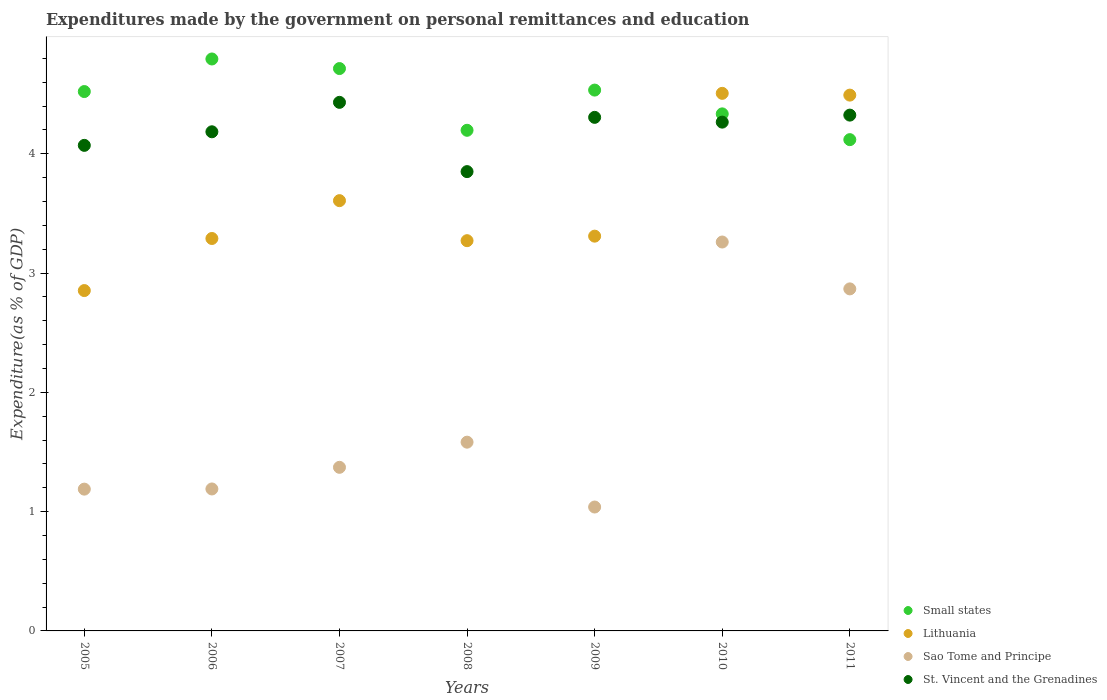Is the number of dotlines equal to the number of legend labels?
Offer a very short reply. Yes. What is the expenditures made by the government on personal remittances and education in St. Vincent and the Grenadines in 2005?
Ensure brevity in your answer.  4.07. Across all years, what is the maximum expenditures made by the government on personal remittances and education in Sao Tome and Principe?
Your answer should be compact. 3.26. Across all years, what is the minimum expenditures made by the government on personal remittances and education in Sao Tome and Principe?
Make the answer very short. 1.04. In which year was the expenditures made by the government on personal remittances and education in Sao Tome and Principe maximum?
Provide a short and direct response. 2010. In which year was the expenditures made by the government on personal remittances and education in Small states minimum?
Your response must be concise. 2011. What is the total expenditures made by the government on personal remittances and education in Lithuania in the graph?
Your answer should be compact. 25.33. What is the difference between the expenditures made by the government on personal remittances and education in Lithuania in 2006 and that in 2009?
Give a very brief answer. -0.02. What is the difference between the expenditures made by the government on personal remittances and education in Lithuania in 2011 and the expenditures made by the government on personal remittances and education in Sao Tome and Principe in 2010?
Your answer should be compact. 1.23. What is the average expenditures made by the government on personal remittances and education in St. Vincent and the Grenadines per year?
Ensure brevity in your answer.  4.2. In the year 2011, what is the difference between the expenditures made by the government on personal remittances and education in Lithuania and expenditures made by the government on personal remittances and education in Small states?
Ensure brevity in your answer.  0.37. What is the ratio of the expenditures made by the government on personal remittances and education in St. Vincent and the Grenadines in 2006 to that in 2008?
Your answer should be compact. 1.09. Is the expenditures made by the government on personal remittances and education in Lithuania in 2007 less than that in 2010?
Offer a very short reply. Yes. What is the difference between the highest and the second highest expenditures made by the government on personal remittances and education in Small states?
Provide a succinct answer. 0.08. What is the difference between the highest and the lowest expenditures made by the government on personal remittances and education in St. Vincent and the Grenadines?
Offer a terse response. 0.58. Is the sum of the expenditures made by the government on personal remittances and education in St. Vincent and the Grenadines in 2006 and 2011 greater than the maximum expenditures made by the government on personal remittances and education in Lithuania across all years?
Offer a terse response. Yes. Is it the case that in every year, the sum of the expenditures made by the government on personal remittances and education in Sao Tome and Principe and expenditures made by the government on personal remittances and education in St. Vincent and the Grenadines  is greater than the sum of expenditures made by the government on personal remittances and education in Lithuania and expenditures made by the government on personal remittances and education in Small states?
Provide a short and direct response. No. Is it the case that in every year, the sum of the expenditures made by the government on personal remittances and education in Small states and expenditures made by the government on personal remittances and education in Lithuania  is greater than the expenditures made by the government on personal remittances and education in Sao Tome and Principe?
Make the answer very short. Yes. Does the expenditures made by the government on personal remittances and education in Sao Tome and Principe monotonically increase over the years?
Offer a terse response. No. Is the expenditures made by the government on personal remittances and education in Small states strictly greater than the expenditures made by the government on personal remittances and education in St. Vincent and the Grenadines over the years?
Ensure brevity in your answer.  No. How many years are there in the graph?
Give a very brief answer. 7. Are the values on the major ticks of Y-axis written in scientific E-notation?
Your answer should be very brief. No. Does the graph contain grids?
Your response must be concise. No. How are the legend labels stacked?
Provide a succinct answer. Vertical. What is the title of the graph?
Ensure brevity in your answer.  Expenditures made by the government on personal remittances and education. What is the label or title of the X-axis?
Offer a very short reply. Years. What is the label or title of the Y-axis?
Your response must be concise. Expenditure(as % of GDP). What is the Expenditure(as % of GDP) of Small states in 2005?
Offer a terse response. 4.52. What is the Expenditure(as % of GDP) of Lithuania in 2005?
Offer a terse response. 2.85. What is the Expenditure(as % of GDP) in Sao Tome and Principe in 2005?
Give a very brief answer. 1.19. What is the Expenditure(as % of GDP) in St. Vincent and the Grenadines in 2005?
Keep it short and to the point. 4.07. What is the Expenditure(as % of GDP) of Small states in 2006?
Provide a short and direct response. 4.79. What is the Expenditure(as % of GDP) of Lithuania in 2006?
Keep it short and to the point. 3.29. What is the Expenditure(as % of GDP) of Sao Tome and Principe in 2006?
Your response must be concise. 1.19. What is the Expenditure(as % of GDP) of St. Vincent and the Grenadines in 2006?
Provide a short and direct response. 4.18. What is the Expenditure(as % of GDP) of Small states in 2007?
Make the answer very short. 4.71. What is the Expenditure(as % of GDP) of Lithuania in 2007?
Ensure brevity in your answer.  3.61. What is the Expenditure(as % of GDP) in Sao Tome and Principe in 2007?
Offer a very short reply. 1.37. What is the Expenditure(as % of GDP) in St. Vincent and the Grenadines in 2007?
Your answer should be compact. 4.43. What is the Expenditure(as % of GDP) of Small states in 2008?
Keep it short and to the point. 4.2. What is the Expenditure(as % of GDP) of Lithuania in 2008?
Provide a short and direct response. 3.27. What is the Expenditure(as % of GDP) of Sao Tome and Principe in 2008?
Give a very brief answer. 1.58. What is the Expenditure(as % of GDP) of St. Vincent and the Grenadines in 2008?
Offer a terse response. 3.85. What is the Expenditure(as % of GDP) in Small states in 2009?
Make the answer very short. 4.53. What is the Expenditure(as % of GDP) in Lithuania in 2009?
Your answer should be compact. 3.31. What is the Expenditure(as % of GDP) of Sao Tome and Principe in 2009?
Your answer should be very brief. 1.04. What is the Expenditure(as % of GDP) in St. Vincent and the Grenadines in 2009?
Your answer should be compact. 4.31. What is the Expenditure(as % of GDP) in Small states in 2010?
Offer a very short reply. 4.33. What is the Expenditure(as % of GDP) of Lithuania in 2010?
Make the answer very short. 4.51. What is the Expenditure(as % of GDP) of Sao Tome and Principe in 2010?
Provide a succinct answer. 3.26. What is the Expenditure(as % of GDP) of St. Vincent and the Grenadines in 2010?
Offer a terse response. 4.27. What is the Expenditure(as % of GDP) in Small states in 2011?
Provide a succinct answer. 4.12. What is the Expenditure(as % of GDP) of Lithuania in 2011?
Offer a terse response. 4.49. What is the Expenditure(as % of GDP) of Sao Tome and Principe in 2011?
Ensure brevity in your answer.  2.87. What is the Expenditure(as % of GDP) in St. Vincent and the Grenadines in 2011?
Provide a succinct answer. 4.32. Across all years, what is the maximum Expenditure(as % of GDP) of Small states?
Keep it short and to the point. 4.79. Across all years, what is the maximum Expenditure(as % of GDP) of Lithuania?
Your answer should be very brief. 4.51. Across all years, what is the maximum Expenditure(as % of GDP) of Sao Tome and Principe?
Your answer should be compact. 3.26. Across all years, what is the maximum Expenditure(as % of GDP) in St. Vincent and the Grenadines?
Offer a very short reply. 4.43. Across all years, what is the minimum Expenditure(as % of GDP) of Small states?
Offer a terse response. 4.12. Across all years, what is the minimum Expenditure(as % of GDP) of Lithuania?
Give a very brief answer. 2.85. Across all years, what is the minimum Expenditure(as % of GDP) of Sao Tome and Principe?
Offer a terse response. 1.04. Across all years, what is the minimum Expenditure(as % of GDP) in St. Vincent and the Grenadines?
Ensure brevity in your answer.  3.85. What is the total Expenditure(as % of GDP) in Small states in the graph?
Give a very brief answer. 31.21. What is the total Expenditure(as % of GDP) in Lithuania in the graph?
Offer a terse response. 25.33. What is the total Expenditure(as % of GDP) of Sao Tome and Principe in the graph?
Keep it short and to the point. 12.5. What is the total Expenditure(as % of GDP) of St. Vincent and the Grenadines in the graph?
Make the answer very short. 29.43. What is the difference between the Expenditure(as % of GDP) in Small states in 2005 and that in 2006?
Your response must be concise. -0.27. What is the difference between the Expenditure(as % of GDP) in Lithuania in 2005 and that in 2006?
Your response must be concise. -0.44. What is the difference between the Expenditure(as % of GDP) of Sao Tome and Principe in 2005 and that in 2006?
Keep it short and to the point. -0. What is the difference between the Expenditure(as % of GDP) in St. Vincent and the Grenadines in 2005 and that in 2006?
Give a very brief answer. -0.11. What is the difference between the Expenditure(as % of GDP) of Small states in 2005 and that in 2007?
Offer a very short reply. -0.19. What is the difference between the Expenditure(as % of GDP) in Lithuania in 2005 and that in 2007?
Your response must be concise. -0.75. What is the difference between the Expenditure(as % of GDP) in Sao Tome and Principe in 2005 and that in 2007?
Keep it short and to the point. -0.18. What is the difference between the Expenditure(as % of GDP) in St. Vincent and the Grenadines in 2005 and that in 2007?
Your response must be concise. -0.36. What is the difference between the Expenditure(as % of GDP) in Small states in 2005 and that in 2008?
Make the answer very short. 0.32. What is the difference between the Expenditure(as % of GDP) in Lithuania in 2005 and that in 2008?
Keep it short and to the point. -0.42. What is the difference between the Expenditure(as % of GDP) of Sao Tome and Principe in 2005 and that in 2008?
Give a very brief answer. -0.39. What is the difference between the Expenditure(as % of GDP) in St. Vincent and the Grenadines in 2005 and that in 2008?
Offer a terse response. 0.22. What is the difference between the Expenditure(as % of GDP) of Small states in 2005 and that in 2009?
Ensure brevity in your answer.  -0.01. What is the difference between the Expenditure(as % of GDP) of Lithuania in 2005 and that in 2009?
Provide a succinct answer. -0.46. What is the difference between the Expenditure(as % of GDP) in St. Vincent and the Grenadines in 2005 and that in 2009?
Make the answer very short. -0.23. What is the difference between the Expenditure(as % of GDP) in Small states in 2005 and that in 2010?
Provide a succinct answer. 0.19. What is the difference between the Expenditure(as % of GDP) of Lithuania in 2005 and that in 2010?
Ensure brevity in your answer.  -1.65. What is the difference between the Expenditure(as % of GDP) in Sao Tome and Principe in 2005 and that in 2010?
Provide a succinct answer. -2.07. What is the difference between the Expenditure(as % of GDP) of St. Vincent and the Grenadines in 2005 and that in 2010?
Keep it short and to the point. -0.19. What is the difference between the Expenditure(as % of GDP) of Small states in 2005 and that in 2011?
Keep it short and to the point. 0.4. What is the difference between the Expenditure(as % of GDP) of Lithuania in 2005 and that in 2011?
Your response must be concise. -1.64. What is the difference between the Expenditure(as % of GDP) in Sao Tome and Principe in 2005 and that in 2011?
Offer a very short reply. -1.68. What is the difference between the Expenditure(as % of GDP) of St. Vincent and the Grenadines in 2005 and that in 2011?
Offer a very short reply. -0.25. What is the difference between the Expenditure(as % of GDP) of Small states in 2006 and that in 2007?
Provide a succinct answer. 0.08. What is the difference between the Expenditure(as % of GDP) in Lithuania in 2006 and that in 2007?
Provide a short and direct response. -0.32. What is the difference between the Expenditure(as % of GDP) of Sao Tome and Principe in 2006 and that in 2007?
Your answer should be compact. -0.18. What is the difference between the Expenditure(as % of GDP) in St. Vincent and the Grenadines in 2006 and that in 2007?
Provide a succinct answer. -0.25. What is the difference between the Expenditure(as % of GDP) of Small states in 2006 and that in 2008?
Your response must be concise. 0.6. What is the difference between the Expenditure(as % of GDP) of Lithuania in 2006 and that in 2008?
Provide a succinct answer. 0.02. What is the difference between the Expenditure(as % of GDP) in Sao Tome and Principe in 2006 and that in 2008?
Provide a succinct answer. -0.39. What is the difference between the Expenditure(as % of GDP) of St. Vincent and the Grenadines in 2006 and that in 2008?
Your answer should be compact. 0.33. What is the difference between the Expenditure(as % of GDP) of Small states in 2006 and that in 2009?
Your answer should be compact. 0.26. What is the difference between the Expenditure(as % of GDP) in Lithuania in 2006 and that in 2009?
Provide a succinct answer. -0.02. What is the difference between the Expenditure(as % of GDP) in Sao Tome and Principe in 2006 and that in 2009?
Keep it short and to the point. 0.15. What is the difference between the Expenditure(as % of GDP) of St. Vincent and the Grenadines in 2006 and that in 2009?
Offer a very short reply. -0.12. What is the difference between the Expenditure(as % of GDP) of Small states in 2006 and that in 2010?
Ensure brevity in your answer.  0.46. What is the difference between the Expenditure(as % of GDP) of Lithuania in 2006 and that in 2010?
Your response must be concise. -1.22. What is the difference between the Expenditure(as % of GDP) of Sao Tome and Principe in 2006 and that in 2010?
Offer a terse response. -2.07. What is the difference between the Expenditure(as % of GDP) in St. Vincent and the Grenadines in 2006 and that in 2010?
Your answer should be very brief. -0.08. What is the difference between the Expenditure(as % of GDP) of Small states in 2006 and that in 2011?
Keep it short and to the point. 0.68. What is the difference between the Expenditure(as % of GDP) of Lithuania in 2006 and that in 2011?
Provide a short and direct response. -1.2. What is the difference between the Expenditure(as % of GDP) of Sao Tome and Principe in 2006 and that in 2011?
Keep it short and to the point. -1.68. What is the difference between the Expenditure(as % of GDP) in St. Vincent and the Grenadines in 2006 and that in 2011?
Provide a succinct answer. -0.14. What is the difference between the Expenditure(as % of GDP) of Small states in 2007 and that in 2008?
Your response must be concise. 0.52. What is the difference between the Expenditure(as % of GDP) in Lithuania in 2007 and that in 2008?
Give a very brief answer. 0.34. What is the difference between the Expenditure(as % of GDP) of Sao Tome and Principe in 2007 and that in 2008?
Ensure brevity in your answer.  -0.21. What is the difference between the Expenditure(as % of GDP) of St. Vincent and the Grenadines in 2007 and that in 2008?
Offer a terse response. 0.58. What is the difference between the Expenditure(as % of GDP) of Small states in 2007 and that in 2009?
Provide a succinct answer. 0.18. What is the difference between the Expenditure(as % of GDP) in Lithuania in 2007 and that in 2009?
Your response must be concise. 0.3. What is the difference between the Expenditure(as % of GDP) in Sao Tome and Principe in 2007 and that in 2009?
Ensure brevity in your answer.  0.33. What is the difference between the Expenditure(as % of GDP) in St. Vincent and the Grenadines in 2007 and that in 2009?
Your answer should be compact. 0.13. What is the difference between the Expenditure(as % of GDP) of Small states in 2007 and that in 2010?
Give a very brief answer. 0.38. What is the difference between the Expenditure(as % of GDP) in Lithuania in 2007 and that in 2010?
Make the answer very short. -0.9. What is the difference between the Expenditure(as % of GDP) of Sao Tome and Principe in 2007 and that in 2010?
Ensure brevity in your answer.  -1.89. What is the difference between the Expenditure(as % of GDP) in St. Vincent and the Grenadines in 2007 and that in 2010?
Keep it short and to the point. 0.17. What is the difference between the Expenditure(as % of GDP) in Small states in 2007 and that in 2011?
Make the answer very short. 0.6. What is the difference between the Expenditure(as % of GDP) of Lithuania in 2007 and that in 2011?
Offer a terse response. -0.88. What is the difference between the Expenditure(as % of GDP) in Sao Tome and Principe in 2007 and that in 2011?
Offer a terse response. -1.5. What is the difference between the Expenditure(as % of GDP) of St. Vincent and the Grenadines in 2007 and that in 2011?
Ensure brevity in your answer.  0.11. What is the difference between the Expenditure(as % of GDP) in Small states in 2008 and that in 2009?
Offer a terse response. -0.34. What is the difference between the Expenditure(as % of GDP) of Lithuania in 2008 and that in 2009?
Provide a short and direct response. -0.04. What is the difference between the Expenditure(as % of GDP) of Sao Tome and Principe in 2008 and that in 2009?
Keep it short and to the point. 0.54. What is the difference between the Expenditure(as % of GDP) of St. Vincent and the Grenadines in 2008 and that in 2009?
Your answer should be compact. -0.45. What is the difference between the Expenditure(as % of GDP) of Small states in 2008 and that in 2010?
Your answer should be very brief. -0.14. What is the difference between the Expenditure(as % of GDP) of Lithuania in 2008 and that in 2010?
Make the answer very short. -1.24. What is the difference between the Expenditure(as % of GDP) of Sao Tome and Principe in 2008 and that in 2010?
Offer a very short reply. -1.68. What is the difference between the Expenditure(as % of GDP) of St. Vincent and the Grenadines in 2008 and that in 2010?
Your answer should be compact. -0.41. What is the difference between the Expenditure(as % of GDP) in Small states in 2008 and that in 2011?
Make the answer very short. 0.08. What is the difference between the Expenditure(as % of GDP) of Lithuania in 2008 and that in 2011?
Your response must be concise. -1.22. What is the difference between the Expenditure(as % of GDP) of Sao Tome and Principe in 2008 and that in 2011?
Provide a short and direct response. -1.29. What is the difference between the Expenditure(as % of GDP) of St. Vincent and the Grenadines in 2008 and that in 2011?
Offer a very short reply. -0.47. What is the difference between the Expenditure(as % of GDP) of Small states in 2009 and that in 2010?
Give a very brief answer. 0.2. What is the difference between the Expenditure(as % of GDP) in Lithuania in 2009 and that in 2010?
Your answer should be compact. -1.2. What is the difference between the Expenditure(as % of GDP) of Sao Tome and Principe in 2009 and that in 2010?
Give a very brief answer. -2.22. What is the difference between the Expenditure(as % of GDP) in St. Vincent and the Grenadines in 2009 and that in 2010?
Ensure brevity in your answer.  0.04. What is the difference between the Expenditure(as % of GDP) of Small states in 2009 and that in 2011?
Your response must be concise. 0.42. What is the difference between the Expenditure(as % of GDP) of Lithuania in 2009 and that in 2011?
Offer a terse response. -1.18. What is the difference between the Expenditure(as % of GDP) in Sao Tome and Principe in 2009 and that in 2011?
Your answer should be very brief. -1.83. What is the difference between the Expenditure(as % of GDP) of St. Vincent and the Grenadines in 2009 and that in 2011?
Ensure brevity in your answer.  -0.02. What is the difference between the Expenditure(as % of GDP) of Small states in 2010 and that in 2011?
Provide a short and direct response. 0.22. What is the difference between the Expenditure(as % of GDP) of Lithuania in 2010 and that in 2011?
Offer a terse response. 0.01. What is the difference between the Expenditure(as % of GDP) in Sao Tome and Principe in 2010 and that in 2011?
Your answer should be very brief. 0.39. What is the difference between the Expenditure(as % of GDP) in St. Vincent and the Grenadines in 2010 and that in 2011?
Offer a very short reply. -0.06. What is the difference between the Expenditure(as % of GDP) of Small states in 2005 and the Expenditure(as % of GDP) of Lithuania in 2006?
Your answer should be very brief. 1.23. What is the difference between the Expenditure(as % of GDP) in Small states in 2005 and the Expenditure(as % of GDP) in Sao Tome and Principe in 2006?
Your response must be concise. 3.33. What is the difference between the Expenditure(as % of GDP) in Small states in 2005 and the Expenditure(as % of GDP) in St. Vincent and the Grenadines in 2006?
Make the answer very short. 0.34. What is the difference between the Expenditure(as % of GDP) of Lithuania in 2005 and the Expenditure(as % of GDP) of Sao Tome and Principe in 2006?
Provide a succinct answer. 1.66. What is the difference between the Expenditure(as % of GDP) in Lithuania in 2005 and the Expenditure(as % of GDP) in St. Vincent and the Grenadines in 2006?
Make the answer very short. -1.33. What is the difference between the Expenditure(as % of GDP) of Sao Tome and Principe in 2005 and the Expenditure(as % of GDP) of St. Vincent and the Grenadines in 2006?
Offer a terse response. -3. What is the difference between the Expenditure(as % of GDP) of Small states in 2005 and the Expenditure(as % of GDP) of Lithuania in 2007?
Ensure brevity in your answer.  0.91. What is the difference between the Expenditure(as % of GDP) in Small states in 2005 and the Expenditure(as % of GDP) in Sao Tome and Principe in 2007?
Your answer should be very brief. 3.15. What is the difference between the Expenditure(as % of GDP) in Small states in 2005 and the Expenditure(as % of GDP) in St. Vincent and the Grenadines in 2007?
Make the answer very short. 0.09. What is the difference between the Expenditure(as % of GDP) of Lithuania in 2005 and the Expenditure(as % of GDP) of Sao Tome and Principe in 2007?
Keep it short and to the point. 1.48. What is the difference between the Expenditure(as % of GDP) in Lithuania in 2005 and the Expenditure(as % of GDP) in St. Vincent and the Grenadines in 2007?
Offer a very short reply. -1.58. What is the difference between the Expenditure(as % of GDP) of Sao Tome and Principe in 2005 and the Expenditure(as % of GDP) of St. Vincent and the Grenadines in 2007?
Provide a short and direct response. -3.24. What is the difference between the Expenditure(as % of GDP) in Small states in 2005 and the Expenditure(as % of GDP) in Lithuania in 2008?
Your answer should be very brief. 1.25. What is the difference between the Expenditure(as % of GDP) of Small states in 2005 and the Expenditure(as % of GDP) of Sao Tome and Principe in 2008?
Offer a very short reply. 2.94. What is the difference between the Expenditure(as % of GDP) in Small states in 2005 and the Expenditure(as % of GDP) in St. Vincent and the Grenadines in 2008?
Give a very brief answer. 0.67. What is the difference between the Expenditure(as % of GDP) in Lithuania in 2005 and the Expenditure(as % of GDP) in Sao Tome and Principe in 2008?
Your answer should be very brief. 1.27. What is the difference between the Expenditure(as % of GDP) in Lithuania in 2005 and the Expenditure(as % of GDP) in St. Vincent and the Grenadines in 2008?
Your response must be concise. -1. What is the difference between the Expenditure(as % of GDP) of Sao Tome and Principe in 2005 and the Expenditure(as % of GDP) of St. Vincent and the Grenadines in 2008?
Provide a succinct answer. -2.66. What is the difference between the Expenditure(as % of GDP) in Small states in 2005 and the Expenditure(as % of GDP) in Lithuania in 2009?
Give a very brief answer. 1.21. What is the difference between the Expenditure(as % of GDP) in Small states in 2005 and the Expenditure(as % of GDP) in Sao Tome and Principe in 2009?
Your answer should be very brief. 3.48. What is the difference between the Expenditure(as % of GDP) of Small states in 2005 and the Expenditure(as % of GDP) of St. Vincent and the Grenadines in 2009?
Your answer should be very brief. 0.22. What is the difference between the Expenditure(as % of GDP) in Lithuania in 2005 and the Expenditure(as % of GDP) in Sao Tome and Principe in 2009?
Give a very brief answer. 1.81. What is the difference between the Expenditure(as % of GDP) of Lithuania in 2005 and the Expenditure(as % of GDP) of St. Vincent and the Grenadines in 2009?
Offer a terse response. -1.45. What is the difference between the Expenditure(as % of GDP) of Sao Tome and Principe in 2005 and the Expenditure(as % of GDP) of St. Vincent and the Grenadines in 2009?
Provide a succinct answer. -3.12. What is the difference between the Expenditure(as % of GDP) in Small states in 2005 and the Expenditure(as % of GDP) in Lithuania in 2010?
Make the answer very short. 0.01. What is the difference between the Expenditure(as % of GDP) in Small states in 2005 and the Expenditure(as % of GDP) in Sao Tome and Principe in 2010?
Provide a succinct answer. 1.26. What is the difference between the Expenditure(as % of GDP) in Small states in 2005 and the Expenditure(as % of GDP) in St. Vincent and the Grenadines in 2010?
Your response must be concise. 0.26. What is the difference between the Expenditure(as % of GDP) of Lithuania in 2005 and the Expenditure(as % of GDP) of Sao Tome and Principe in 2010?
Ensure brevity in your answer.  -0.41. What is the difference between the Expenditure(as % of GDP) of Lithuania in 2005 and the Expenditure(as % of GDP) of St. Vincent and the Grenadines in 2010?
Ensure brevity in your answer.  -1.41. What is the difference between the Expenditure(as % of GDP) in Sao Tome and Principe in 2005 and the Expenditure(as % of GDP) in St. Vincent and the Grenadines in 2010?
Provide a short and direct response. -3.08. What is the difference between the Expenditure(as % of GDP) of Small states in 2005 and the Expenditure(as % of GDP) of Lithuania in 2011?
Provide a short and direct response. 0.03. What is the difference between the Expenditure(as % of GDP) of Small states in 2005 and the Expenditure(as % of GDP) of Sao Tome and Principe in 2011?
Your response must be concise. 1.65. What is the difference between the Expenditure(as % of GDP) of Small states in 2005 and the Expenditure(as % of GDP) of St. Vincent and the Grenadines in 2011?
Your response must be concise. 0.2. What is the difference between the Expenditure(as % of GDP) in Lithuania in 2005 and the Expenditure(as % of GDP) in Sao Tome and Principe in 2011?
Ensure brevity in your answer.  -0.01. What is the difference between the Expenditure(as % of GDP) of Lithuania in 2005 and the Expenditure(as % of GDP) of St. Vincent and the Grenadines in 2011?
Offer a terse response. -1.47. What is the difference between the Expenditure(as % of GDP) in Sao Tome and Principe in 2005 and the Expenditure(as % of GDP) in St. Vincent and the Grenadines in 2011?
Offer a very short reply. -3.14. What is the difference between the Expenditure(as % of GDP) of Small states in 2006 and the Expenditure(as % of GDP) of Lithuania in 2007?
Keep it short and to the point. 1.19. What is the difference between the Expenditure(as % of GDP) of Small states in 2006 and the Expenditure(as % of GDP) of Sao Tome and Principe in 2007?
Keep it short and to the point. 3.42. What is the difference between the Expenditure(as % of GDP) in Small states in 2006 and the Expenditure(as % of GDP) in St. Vincent and the Grenadines in 2007?
Provide a short and direct response. 0.36. What is the difference between the Expenditure(as % of GDP) of Lithuania in 2006 and the Expenditure(as % of GDP) of Sao Tome and Principe in 2007?
Ensure brevity in your answer.  1.92. What is the difference between the Expenditure(as % of GDP) of Lithuania in 2006 and the Expenditure(as % of GDP) of St. Vincent and the Grenadines in 2007?
Provide a succinct answer. -1.14. What is the difference between the Expenditure(as % of GDP) in Sao Tome and Principe in 2006 and the Expenditure(as % of GDP) in St. Vincent and the Grenadines in 2007?
Provide a short and direct response. -3.24. What is the difference between the Expenditure(as % of GDP) in Small states in 2006 and the Expenditure(as % of GDP) in Lithuania in 2008?
Your answer should be compact. 1.52. What is the difference between the Expenditure(as % of GDP) in Small states in 2006 and the Expenditure(as % of GDP) in Sao Tome and Principe in 2008?
Your answer should be compact. 3.21. What is the difference between the Expenditure(as % of GDP) in Small states in 2006 and the Expenditure(as % of GDP) in St. Vincent and the Grenadines in 2008?
Provide a succinct answer. 0.94. What is the difference between the Expenditure(as % of GDP) in Lithuania in 2006 and the Expenditure(as % of GDP) in Sao Tome and Principe in 2008?
Provide a short and direct response. 1.71. What is the difference between the Expenditure(as % of GDP) in Lithuania in 2006 and the Expenditure(as % of GDP) in St. Vincent and the Grenadines in 2008?
Give a very brief answer. -0.56. What is the difference between the Expenditure(as % of GDP) of Sao Tome and Principe in 2006 and the Expenditure(as % of GDP) of St. Vincent and the Grenadines in 2008?
Give a very brief answer. -2.66. What is the difference between the Expenditure(as % of GDP) in Small states in 2006 and the Expenditure(as % of GDP) in Lithuania in 2009?
Give a very brief answer. 1.49. What is the difference between the Expenditure(as % of GDP) in Small states in 2006 and the Expenditure(as % of GDP) in Sao Tome and Principe in 2009?
Offer a terse response. 3.76. What is the difference between the Expenditure(as % of GDP) of Small states in 2006 and the Expenditure(as % of GDP) of St. Vincent and the Grenadines in 2009?
Give a very brief answer. 0.49. What is the difference between the Expenditure(as % of GDP) in Lithuania in 2006 and the Expenditure(as % of GDP) in Sao Tome and Principe in 2009?
Make the answer very short. 2.25. What is the difference between the Expenditure(as % of GDP) in Lithuania in 2006 and the Expenditure(as % of GDP) in St. Vincent and the Grenadines in 2009?
Make the answer very short. -1.02. What is the difference between the Expenditure(as % of GDP) of Sao Tome and Principe in 2006 and the Expenditure(as % of GDP) of St. Vincent and the Grenadines in 2009?
Your response must be concise. -3.12. What is the difference between the Expenditure(as % of GDP) of Small states in 2006 and the Expenditure(as % of GDP) of Lithuania in 2010?
Ensure brevity in your answer.  0.29. What is the difference between the Expenditure(as % of GDP) in Small states in 2006 and the Expenditure(as % of GDP) in Sao Tome and Principe in 2010?
Offer a very short reply. 1.53. What is the difference between the Expenditure(as % of GDP) of Small states in 2006 and the Expenditure(as % of GDP) of St. Vincent and the Grenadines in 2010?
Your answer should be very brief. 0.53. What is the difference between the Expenditure(as % of GDP) in Lithuania in 2006 and the Expenditure(as % of GDP) in Sao Tome and Principe in 2010?
Keep it short and to the point. 0.03. What is the difference between the Expenditure(as % of GDP) of Lithuania in 2006 and the Expenditure(as % of GDP) of St. Vincent and the Grenadines in 2010?
Ensure brevity in your answer.  -0.98. What is the difference between the Expenditure(as % of GDP) of Sao Tome and Principe in 2006 and the Expenditure(as % of GDP) of St. Vincent and the Grenadines in 2010?
Your response must be concise. -3.08. What is the difference between the Expenditure(as % of GDP) of Small states in 2006 and the Expenditure(as % of GDP) of Lithuania in 2011?
Provide a succinct answer. 0.3. What is the difference between the Expenditure(as % of GDP) of Small states in 2006 and the Expenditure(as % of GDP) of Sao Tome and Principe in 2011?
Your answer should be compact. 1.93. What is the difference between the Expenditure(as % of GDP) in Small states in 2006 and the Expenditure(as % of GDP) in St. Vincent and the Grenadines in 2011?
Give a very brief answer. 0.47. What is the difference between the Expenditure(as % of GDP) in Lithuania in 2006 and the Expenditure(as % of GDP) in Sao Tome and Principe in 2011?
Keep it short and to the point. 0.42. What is the difference between the Expenditure(as % of GDP) of Lithuania in 2006 and the Expenditure(as % of GDP) of St. Vincent and the Grenadines in 2011?
Keep it short and to the point. -1.03. What is the difference between the Expenditure(as % of GDP) in Sao Tome and Principe in 2006 and the Expenditure(as % of GDP) in St. Vincent and the Grenadines in 2011?
Offer a very short reply. -3.13. What is the difference between the Expenditure(as % of GDP) in Small states in 2007 and the Expenditure(as % of GDP) in Lithuania in 2008?
Make the answer very short. 1.44. What is the difference between the Expenditure(as % of GDP) of Small states in 2007 and the Expenditure(as % of GDP) of Sao Tome and Principe in 2008?
Your answer should be very brief. 3.13. What is the difference between the Expenditure(as % of GDP) of Small states in 2007 and the Expenditure(as % of GDP) of St. Vincent and the Grenadines in 2008?
Make the answer very short. 0.86. What is the difference between the Expenditure(as % of GDP) of Lithuania in 2007 and the Expenditure(as % of GDP) of Sao Tome and Principe in 2008?
Keep it short and to the point. 2.02. What is the difference between the Expenditure(as % of GDP) in Lithuania in 2007 and the Expenditure(as % of GDP) in St. Vincent and the Grenadines in 2008?
Make the answer very short. -0.24. What is the difference between the Expenditure(as % of GDP) in Sao Tome and Principe in 2007 and the Expenditure(as % of GDP) in St. Vincent and the Grenadines in 2008?
Give a very brief answer. -2.48. What is the difference between the Expenditure(as % of GDP) of Small states in 2007 and the Expenditure(as % of GDP) of Lithuania in 2009?
Keep it short and to the point. 1.41. What is the difference between the Expenditure(as % of GDP) of Small states in 2007 and the Expenditure(as % of GDP) of Sao Tome and Principe in 2009?
Your response must be concise. 3.68. What is the difference between the Expenditure(as % of GDP) of Small states in 2007 and the Expenditure(as % of GDP) of St. Vincent and the Grenadines in 2009?
Offer a very short reply. 0.41. What is the difference between the Expenditure(as % of GDP) in Lithuania in 2007 and the Expenditure(as % of GDP) in Sao Tome and Principe in 2009?
Offer a terse response. 2.57. What is the difference between the Expenditure(as % of GDP) of Lithuania in 2007 and the Expenditure(as % of GDP) of St. Vincent and the Grenadines in 2009?
Offer a very short reply. -0.7. What is the difference between the Expenditure(as % of GDP) in Sao Tome and Principe in 2007 and the Expenditure(as % of GDP) in St. Vincent and the Grenadines in 2009?
Offer a terse response. -2.93. What is the difference between the Expenditure(as % of GDP) in Small states in 2007 and the Expenditure(as % of GDP) in Lithuania in 2010?
Ensure brevity in your answer.  0.21. What is the difference between the Expenditure(as % of GDP) of Small states in 2007 and the Expenditure(as % of GDP) of Sao Tome and Principe in 2010?
Keep it short and to the point. 1.45. What is the difference between the Expenditure(as % of GDP) in Small states in 2007 and the Expenditure(as % of GDP) in St. Vincent and the Grenadines in 2010?
Your answer should be compact. 0.45. What is the difference between the Expenditure(as % of GDP) of Lithuania in 2007 and the Expenditure(as % of GDP) of Sao Tome and Principe in 2010?
Keep it short and to the point. 0.35. What is the difference between the Expenditure(as % of GDP) of Lithuania in 2007 and the Expenditure(as % of GDP) of St. Vincent and the Grenadines in 2010?
Make the answer very short. -0.66. What is the difference between the Expenditure(as % of GDP) in Sao Tome and Principe in 2007 and the Expenditure(as % of GDP) in St. Vincent and the Grenadines in 2010?
Ensure brevity in your answer.  -2.89. What is the difference between the Expenditure(as % of GDP) in Small states in 2007 and the Expenditure(as % of GDP) in Lithuania in 2011?
Provide a succinct answer. 0.22. What is the difference between the Expenditure(as % of GDP) in Small states in 2007 and the Expenditure(as % of GDP) in Sao Tome and Principe in 2011?
Your response must be concise. 1.85. What is the difference between the Expenditure(as % of GDP) of Small states in 2007 and the Expenditure(as % of GDP) of St. Vincent and the Grenadines in 2011?
Keep it short and to the point. 0.39. What is the difference between the Expenditure(as % of GDP) in Lithuania in 2007 and the Expenditure(as % of GDP) in Sao Tome and Principe in 2011?
Offer a very short reply. 0.74. What is the difference between the Expenditure(as % of GDP) in Lithuania in 2007 and the Expenditure(as % of GDP) in St. Vincent and the Grenadines in 2011?
Ensure brevity in your answer.  -0.72. What is the difference between the Expenditure(as % of GDP) of Sao Tome and Principe in 2007 and the Expenditure(as % of GDP) of St. Vincent and the Grenadines in 2011?
Provide a succinct answer. -2.95. What is the difference between the Expenditure(as % of GDP) of Small states in 2008 and the Expenditure(as % of GDP) of Lithuania in 2009?
Provide a short and direct response. 0.89. What is the difference between the Expenditure(as % of GDP) in Small states in 2008 and the Expenditure(as % of GDP) in Sao Tome and Principe in 2009?
Your response must be concise. 3.16. What is the difference between the Expenditure(as % of GDP) of Small states in 2008 and the Expenditure(as % of GDP) of St. Vincent and the Grenadines in 2009?
Ensure brevity in your answer.  -0.11. What is the difference between the Expenditure(as % of GDP) in Lithuania in 2008 and the Expenditure(as % of GDP) in Sao Tome and Principe in 2009?
Make the answer very short. 2.23. What is the difference between the Expenditure(as % of GDP) of Lithuania in 2008 and the Expenditure(as % of GDP) of St. Vincent and the Grenadines in 2009?
Provide a succinct answer. -1.03. What is the difference between the Expenditure(as % of GDP) of Sao Tome and Principe in 2008 and the Expenditure(as % of GDP) of St. Vincent and the Grenadines in 2009?
Make the answer very short. -2.72. What is the difference between the Expenditure(as % of GDP) of Small states in 2008 and the Expenditure(as % of GDP) of Lithuania in 2010?
Provide a short and direct response. -0.31. What is the difference between the Expenditure(as % of GDP) in Small states in 2008 and the Expenditure(as % of GDP) in Sao Tome and Principe in 2010?
Your answer should be compact. 0.94. What is the difference between the Expenditure(as % of GDP) in Small states in 2008 and the Expenditure(as % of GDP) in St. Vincent and the Grenadines in 2010?
Your answer should be very brief. -0.07. What is the difference between the Expenditure(as % of GDP) of Lithuania in 2008 and the Expenditure(as % of GDP) of Sao Tome and Principe in 2010?
Keep it short and to the point. 0.01. What is the difference between the Expenditure(as % of GDP) of Lithuania in 2008 and the Expenditure(as % of GDP) of St. Vincent and the Grenadines in 2010?
Ensure brevity in your answer.  -0.99. What is the difference between the Expenditure(as % of GDP) of Sao Tome and Principe in 2008 and the Expenditure(as % of GDP) of St. Vincent and the Grenadines in 2010?
Provide a succinct answer. -2.68. What is the difference between the Expenditure(as % of GDP) in Small states in 2008 and the Expenditure(as % of GDP) in Lithuania in 2011?
Give a very brief answer. -0.29. What is the difference between the Expenditure(as % of GDP) of Small states in 2008 and the Expenditure(as % of GDP) of Sao Tome and Principe in 2011?
Your response must be concise. 1.33. What is the difference between the Expenditure(as % of GDP) of Small states in 2008 and the Expenditure(as % of GDP) of St. Vincent and the Grenadines in 2011?
Give a very brief answer. -0.13. What is the difference between the Expenditure(as % of GDP) in Lithuania in 2008 and the Expenditure(as % of GDP) in Sao Tome and Principe in 2011?
Your answer should be very brief. 0.4. What is the difference between the Expenditure(as % of GDP) in Lithuania in 2008 and the Expenditure(as % of GDP) in St. Vincent and the Grenadines in 2011?
Your answer should be very brief. -1.05. What is the difference between the Expenditure(as % of GDP) of Sao Tome and Principe in 2008 and the Expenditure(as % of GDP) of St. Vincent and the Grenadines in 2011?
Your answer should be compact. -2.74. What is the difference between the Expenditure(as % of GDP) of Small states in 2009 and the Expenditure(as % of GDP) of Lithuania in 2010?
Your answer should be very brief. 0.03. What is the difference between the Expenditure(as % of GDP) in Small states in 2009 and the Expenditure(as % of GDP) in Sao Tome and Principe in 2010?
Your answer should be very brief. 1.27. What is the difference between the Expenditure(as % of GDP) in Small states in 2009 and the Expenditure(as % of GDP) in St. Vincent and the Grenadines in 2010?
Give a very brief answer. 0.27. What is the difference between the Expenditure(as % of GDP) of Lithuania in 2009 and the Expenditure(as % of GDP) of Sao Tome and Principe in 2010?
Your answer should be compact. 0.05. What is the difference between the Expenditure(as % of GDP) in Lithuania in 2009 and the Expenditure(as % of GDP) in St. Vincent and the Grenadines in 2010?
Ensure brevity in your answer.  -0.96. What is the difference between the Expenditure(as % of GDP) of Sao Tome and Principe in 2009 and the Expenditure(as % of GDP) of St. Vincent and the Grenadines in 2010?
Your answer should be very brief. -3.23. What is the difference between the Expenditure(as % of GDP) in Small states in 2009 and the Expenditure(as % of GDP) in Lithuania in 2011?
Your answer should be very brief. 0.04. What is the difference between the Expenditure(as % of GDP) of Small states in 2009 and the Expenditure(as % of GDP) of Sao Tome and Principe in 2011?
Your answer should be compact. 1.67. What is the difference between the Expenditure(as % of GDP) in Small states in 2009 and the Expenditure(as % of GDP) in St. Vincent and the Grenadines in 2011?
Your response must be concise. 0.21. What is the difference between the Expenditure(as % of GDP) in Lithuania in 2009 and the Expenditure(as % of GDP) in Sao Tome and Principe in 2011?
Keep it short and to the point. 0.44. What is the difference between the Expenditure(as % of GDP) in Lithuania in 2009 and the Expenditure(as % of GDP) in St. Vincent and the Grenadines in 2011?
Give a very brief answer. -1.01. What is the difference between the Expenditure(as % of GDP) in Sao Tome and Principe in 2009 and the Expenditure(as % of GDP) in St. Vincent and the Grenadines in 2011?
Give a very brief answer. -3.29. What is the difference between the Expenditure(as % of GDP) in Small states in 2010 and the Expenditure(as % of GDP) in Lithuania in 2011?
Offer a very short reply. -0.16. What is the difference between the Expenditure(as % of GDP) of Small states in 2010 and the Expenditure(as % of GDP) of Sao Tome and Principe in 2011?
Your response must be concise. 1.47. What is the difference between the Expenditure(as % of GDP) of Small states in 2010 and the Expenditure(as % of GDP) of St. Vincent and the Grenadines in 2011?
Offer a very short reply. 0.01. What is the difference between the Expenditure(as % of GDP) in Lithuania in 2010 and the Expenditure(as % of GDP) in Sao Tome and Principe in 2011?
Provide a short and direct response. 1.64. What is the difference between the Expenditure(as % of GDP) of Lithuania in 2010 and the Expenditure(as % of GDP) of St. Vincent and the Grenadines in 2011?
Ensure brevity in your answer.  0.18. What is the difference between the Expenditure(as % of GDP) in Sao Tome and Principe in 2010 and the Expenditure(as % of GDP) in St. Vincent and the Grenadines in 2011?
Your answer should be very brief. -1.06. What is the average Expenditure(as % of GDP) of Small states per year?
Keep it short and to the point. 4.46. What is the average Expenditure(as % of GDP) in Lithuania per year?
Offer a terse response. 3.62. What is the average Expenditure(as % of GDP) in Sao Tome and Principe per year?
Offer a very short reply. 1.79. What is the average Expenditure(as % of GDP) of St. Vincent and the Grenadines per year?
Make the answer very short. 4.2. In the year 2005, what is the difference between the Expenditure(as % of GDP) in Small states and Expenditure(as % of GDP) in Lithuania?
Your response must be concise. 1.67. In the year 2005, what is the difference between the Expenditure(as % of GDP) of Small states and Expenditure(as % of GDP) of Sao Tome and Principe?
Offer a terse response. 3.33. In the year 2005, what is the difference between the Expenditure(as % of GDP) of Small states and Expenditure(as % of GDP) of St. Vincent and the Grenadines?
Keep it short and to the point. 0.45. In the year 2005, what is the difference between the Expenditure(as % of GDP) in Lithuania and Expenditure(as % of GDP) in Sao Tome and Principe?
Make the answer very short. 1.66. In the year 2005, what is the difference between the Expenditure(as % of GDP) of Lithuania and Expenditure(as % of GDP) of St. Vincent and the Grenadines?
Your response must be concise. -1.22. In the year 2005, what is the difference between the Expenditure(as % of GDP) in Sao Tome and Principe and Expenditure(as % of GDP) in St. Vincent and the Grenadines?
Keep it short and to the point. -2.88. In the year 2006, what is the difference between the Expenditure(as % of GDP) in Small states and Expenditure(as % of GDP) in Lithuania?
Give a very brief answer. 1.5. In the year 2006, what is the difference between the Expenditure(as % of GDP) of Small states and Expenditure(as % of GDP) of Sao Tome and Principe?
Make the answer very short. 3.6. In the year 2006, what is the difference between the Expenditure(as % of GDP) in Small states and Expenditure(as % of GDP) in St. Vincent and the Grenadines?
Your answer should be compact. 0.61. In the year 2006, what is the difference between the Expenditure(as % of GDP) in Lithuania and Expenditure(as % of GDP) in Sao Tome and Principe?
Give a very brief answer. 2.1. In the year 2006, what is the difference between the Expenditure(as % of GDP) in Lithuania and Expenditure(as % of GDP) in St. Vincent and the Grenadines?
Your response must be concise. -0.89. In the year 2006, what is the difference between the Expenditure(as % of GDP) in Sao Tome and Principe and Expenditure(as % of GDP) in St. Vincent and the Grenadines?
Offer a terse response. -2.99. In the year 2007, what is the difference between the Expenditure(as % of GDP) of Small states and Expenditure(as % of GDP) of Lithuania?
Give a very brief answer. 1.11. In the year 2007, what is the difference between the Expenditure(as % of GDP) in Small states and Expenditure(as % of GDP) in Sao Tome and Principe?
Provide a short and direct response. 3.34. In the year 2007, what is the difference between the Expenditure(as % of GDP) of Small states and Expenditure(as % of GDP) of St. Vincent and the Grenadines?
Your answer should be compact. 0.28. In the year 2007, what is the difference between the Expenditure(as % of GDP) in Lithuania and Expenditure(as % of GDP) in Sao Tome and Principe?
Your response must be concise. 2.24. In the year 2007, what is the difference between the Expenditure(as % of GDP) in Lithuania and Expenditure(as % of GDP) in St. Vincent and the Grenadines?
Offer a terse response. -0.82. In the year 2007, what is the difference between the Expenditure(as % of GDP) in Sao Tome and Principe and Expenditure(as % of GDP) in St. Vincent and the Grenadines?
Keep it short and to the point. -3.06. In the year 2008, what is the difference between the Expenditure(as % of GDP) of Small states and Expenditure(as % of GDP) of Lithuania?
Offer a terse response. 0.93. In the year 2008, what is the difference between the Expenditure(as % of GDP) of Small states and Expenditure(as % of GDP) of Sao Tome and Principe?
Keep it short and to the point. 2.61. In the year 2008, what is the difference between the Expenditure(as % of GDP) in Small states and Expenditure(as % of GDP) in St. Vincent and the Grenadines?
Provide a short and direct response. 0.35. In the year 2008, what is the difference between the Expenditure(as % of GDP) of Lithuania and Expenditure(as % of GDP) of Sao Tome and Principe?
Ensure brevity in your answer.  1.69. In the year 2008, what is the difference between the Expenditure(as % of GDP) of Lithuania and Expenditure(as % of GDP) of St. Vincent and the Grenadines?
Your answer should be very brief. -0.58. In the year 2008, what is the difference between the Expenditure(as % of GDP) of Sao Tome and Principe and Expenditure(as % of GDP) of St. Vincent and the Grenadines?
Your answer should be very brief. -2.27. In the year 2009, what is the difference between the Expenditure(as % of GDP) in Small states and Expenditure(as % of GDP) in Lithuania?
Make the answer very short. 1.22. In the year 2009, what is the difference between the Expenditure(as % of GDP) in Small states and Expenditure(as % of GDP) in Sao Tome and Principe?
Ensure brevity in your answer.  3.5. In the year 2009, what is the difference between the Expenditure(as % of GDP) in Small states and Expenditure(as % of GDP) in St. Vincent and the Grenadines?
Ensure brevity in your answer.  0.23. In the year 2009, what is the difference between the Expenditure(as % of GDP) of Lithuania and Expenditure(as % of GDP) of Sao Tome and Principe?
Offer a terse response. 2.27. In the year 2009, what is the difference between the Expenditure(as % of GDP) in Lithuania and Expenditure(as % of GDP) in St. Vincent and the Grenadines?
Offer a terse response. -1. In the year 2009, what is the difference between the Expenditure(as % of GDP) of Sao Tome and Principe and Expenditure(as % of GDP) of St. Vincent and the Grenadines?
Make the answer very short. -3.27. In the year 2010, what is the difference between the Expenditure(as % of GDP) of Small states and Expenditure(as % of GDP) of Lithuania?
Offer a very short reply. -0.17. In the year 2010, what is the difference between the Expenditure(as % of GDP) in Small states and Expenditure(as % of GDP) in Sao Tome and Principe?
Keep it short and to the point. 1.07. In the year 2010, what is the difference between the Expenditure(as % of GDP) of Small states and Expenditure(as % of GDP) of St. Vincent and the Grenadines?
Provide a short and direct response. 0.07. In the year 2010, what is the difference between the Expenditure(as % of GDP) of Lithuania and Expenditure(as % of GDP) of Sao Tome and Principe?
Your answer should be compact. 1.25. In the year 2010, what is the difference between the Expenditure(as % of GDP) in Lithuania and Expenditure(as % of GDP) in St. Vincent and the Grenadines?
Ensure brevity in your answer.  0.24. In the year 2010, what is the difference between the Expenditure(as % of GDP) in Sao Tome and Principe and Expenditure(as % of GDP) in St. Vincent and the Grenadines?
Offer a terse response. -1. In the year 2011, what is the difference between the Expenditure(as % of GDP) of Small states and Expenditure(as % of GDP) of Lithuania?
Make the answer very short. -0.37. In the year 2011, what is the difference between the Expenditure(as % of GDP) in Small states and Expenditure(as % of GDP) in Sao Tome and Principe?
Ensure brevity in your answer.  1.25. In the year 2011, what is the difference between the Expenditure(as % of GDP) of Small states and Expenditure(as % of GDP) of St. Vincent and the Grenadines?
Your response must be concise. -0.21. In the year 2011, what is the difference between the Expenditure(as % of GDP) in Lithuania and Expenditure(as % of GDP) in Sao Tome and Principe?
Offer a very short reply. 1.62. In the year 2011, what is the difference between the Expenditure(as % of GDP) in Lithuania and Expenditure(as % of GDP) in St. Vincent and the Grenadines?
Make the answer very short. 0.17. In the year 2011, what is the difference between the Expenditure(as % of GDP) in Sao Tome and Principe and Expenditure(as % of GDP) in St. Vincent and the Grenadines?
Ensure brevity in your answer.  -1.46. What is the ratio of the Expenditure(as % of GDP) in Small states in 2005 to that in 2006?
Your response must be concise. 0.94. What is the ratio of the Expenditure(as % of GDP) of Lithuania in 2005 to that in 2006?
Keep it short and to the point. 0.87. What is the ratio of the Expenditure(as % of GDP) of St. Vincent and the Grenadines in 2005 to that in 2006?
Provide a short and direct response. 0.97. What is the ratio of the Expenditure(as % of GDP) in Small states in 2005 to that in 2007?
Offer a terse response. 0.96. What is the ratio of the Expenditure(as % of GDP) in Lithuania in 2005 to that in 2007?
Your response must be concise. 0.79. What is the ratio of the Expenditure(as % of GDP) in Sao Tome and Principe in 2005 to that in 2007?
Provide a short and direct response. 0.87. What is the ratio of the Expenditure(as % of GDP) of St. Vincent and the Grenadines in 2005 to that in 2007?
Offer a terse response. 0.92. What is the ratio of the Expenditure(as % of GDP) in Small states in 2005 to that in 2008?
Provide a succinct answer. 1.08. What is the ratio of the Expenditure(as % of GDP) in Lithuania in 2005 to that in 2008?
Provide a short and direct response. 0.87. What is the ratio of the Expenditure(as % of GDP) of Sao Tome and Principe in 2005 to that in 2008?
Offer a very short reply. 0.75. What is the ratio of the Expenditure(as % of GDP) in St. Vincent and the Grenadines in 2005 to that in 2008?
Your response must be concise. 1.06. What is the ratio of the Expenditure(as % of GDP) in Small states in 2005 to that in 2009?
Provide a short and direct response. 1. What is the ratio of the Expenditure(as % of GDP) of Lithuania in 2005 to that in 2009?
Offer a very short reply. 0.86. What is the ratio of the Expenditure(as % of GDP) in Sao Tome and Principe in 2005 to that in 2009?
Give a very brief answer. 1.14. What is the ratio of the Expenditure(as % of GDP) in St. Vincent and the Grenadines in 2005 to that in 2009?
Keep it short and to the point. 0.95. What is the ratio of the Expenditure(as % of GDP) in Small states in 2005 to that in 2010?
Provide a succinct answer. 1.04. What is the ratio of the Expenditure(as % of GDP) in Lithuania in 2005 to that in 2010?
Keep it short and to the point. 0.63. What is the ratio of the Expenditure(as % of GDP) of Sao Tome and Principe in 2005 to that in 2010?
Your answer should be compact. 0.36. What is the ratio of the Expenditure(as % of GDP) in St. Vincent and the Grenadines in 2005 to that in 2010?
Make the answer very short. 0.95. What is the ratio of the Expenditure(as % of GDP) in Small states in 2005 to that in 2011?
Your answer should be very brief. 1.1. What is the ratio of the Expenditure(as % of GDP) of Lithuania in 2005 to that in 2011?
Provide a succinct answer. 0.64. What is the ratio of the Expenditure(as % of GDP) of Sao Tome and Principe in 2005 to that in 2011?
Offer a very short reply. 0.41. What is the ratio of the Expenditure(as % of GDP) of St. Vincent and the Grenadines in 2005 to that in 2011?
Offer a terse response. 0.94. What is the ratio of the Expenditure(as % of GDP) of Lithuania in 2006 to that in 2007?
Give a very brief answer. 0.91. What is the ratio of the Expenditure(as % of GDP) of Sao Tome and Principe in 2006 to that in 2007?
Offer a terse response. 0.87. What is the ratio of the Expenditure(as % of GDP) in St. Vincent and the Grenadines in 2006 to that in 2007?
Make the answer very short. 0.94. What is the ratio of the Expenditure(as % of GDP) in Small states in 2006 to that in 2008?
Offer a terse response. 1.14. What is the ratio of the Expenditure(as % of GDP) in Lithuania in 2006 to that in 2008?
Ensure brevity in your answer.  1.01. What is the ratio of the Expenditure(as % of GDP) of Sao Tome and Principe in 2006 to that in 2008?
Make the answer very short. 0.75. What is the ratio of the Expenditure(as % of GDP) of St. Vincent and the Grenadines in 2006 to that in 2008?
Ensure brevity in your answer.  1.09. What is the ratio of the Expenditure(as % of GDP) of Small states in 2006 to that in 2009?
Make the answer very short. 1.06. What is the ratio of the Expenditure(as % of GDP) in Lithuania in 2006 to that in 2009?
Your response must be concise. 0.99. What is the ratio of the Expenditure(as % of GDP) in Sao Tome and Principe in 2006 to that in 2009?
Ensure brevity in your answer.  1.15. What is the ratio of the Expenditure(as % of GDP) of St. Vincent and the Grenadines in 2006 to that in 2009?
Make the answer very short. 0.97. What is the ratio of the Expenditure(as % of GDP) of Small states in 2006 to that in 2010?
Provide a succinct answer. 1.11. What is the ratio of the Expenditure(as % of GDP) in Lithuania in 2006 to that in 2010?
Your response must be concise. 0.73. What is the ratio of the Expenditure(as % of GDP) in Sao Tome and Principe in 2006 to that in 2010?
Provide a short and direct response. 0.36. What is the ratio of the Expenditure(as % of GDP) in Small states in 2006 to that in 2011?
Offer a very short reply. 1.16. What is the ratio of the Expenditure(as % of GDP) of Lithuania in 2006 to that in 2011?
Offer a terse response. 0.73. What is the ratio of the Expenditure(as % of GDP) of Sao Tome and Principe in 2006 to that in 2011?
Offer a terse response. 0.42. What is the ratio of the Expenditure(as % of GDP) in Small states in 2007 to that in 2008?
Your answer should be compact. 1.12. What is the ratio of the Expenditure(as % of GDP) in Lithuania in 2007 to that in 2008?
Provide a succinct answer. 1.1. What is the ratio of the Expenditure(as % of GDP) in Sao Tome and Principe in 2007 to that in 2008?
Offer a very short reply. 0.87. What is the ratio of the Expenditure(as % of GDP) in St. Vincent and the Grenadines in 2007 to that in 2008?
Keep it short and to the point. 1.15. What is the ratio of the Expenditure(as % of GDP) of Small states in 2007 to that in 2009?
Ensure brevity in your answer.  1.04. What is the ratio of the Expenditure(as % of GDP) in Lithuania in 2007 to that in 2009?
Ensure brevity in your answer.  1.09. What is the ratio of the Expenditure(as % of GDP) in Sao Tome and Principe in 2007 to that in 2009?
Your answer should be compact. 1.32. What is the ratio of the Expenditure(as % of GDP) in St. Vincent and the Grenadines in 2007 to that in 2009?
Ensure brevity in your answer.  1.03. What is the ratio of the Expenditure(as % of GDP) in Small states in 2007 to that in 2010?
Provide a succinct answer. 1.09. What is the ratio of the Expenditure(as % of GDP) of Lithuania in 2007 to that in 2010?
Offer a very short reply. 0.8. What is the ratio of the Expenditure(as % of GDP) in Sao Tome and Principe in 2007 to that in 2010?
Provide a succinct answer. 0.42. What is the ratio of the Expenditure(as % of GDP) in St. Vincent and the Grenadines in 2007 to that in 2010?
Your answer should be compact. 1.04. What is the ratio of the Expenditure(as % of GDP) in Small states in 2007 to that in 2011?
Your answer should be very brief. 1.14. What is the ratio of the Expenditure(as % of GDP) of Lithuania in 2007 to that in 2011?
Make the answer very short. 0.8. What is the ratio of the Expenditure(as % of GDP) of Sao Tome and Principe in 2007 to that in 2011?
Your answer should be very brief. 0.48. What is the ratio of the Expenditure(as % of GDP) of St. Vincent and the Grenadines in 2007 to that in 2011?
Offer a terse response. 1.02. What is the ratio of the Expenditure(as % of GDP) in Small states in 2008 to that in 2009?
Make the answer very short. 0.93. What is the ratio of the Expenditure(as % of GDP) of Sao Tome and Principe in 2008 to that in 2009?
Give a very brief answer. 1.52. What is the ratio of the Expenditure(as % of GDP) in St. Vincent and the Grenadines in 2008 to that in 2009?
Provide a succinct answer. 0.89. What is the ratio of the Expenditure(as % of GDP) of Small states in 2008 to that in 2010?
Make the answer very short. 0.97. What is the ratio of the Expenditure(as % of GDP) of Lithuania in 2008 to that in 2010?
Offer a terse response. 0.73. What is the ratio of the Expenditure(as % of GDP) in Sao Tome and Principe in 2008 to that in 2010?
Give a very brief answer. 0.49. What is the ratio of the Expenditure(as % of GDP) in St. Vincent and the Grenadines in 2008 to that in 2010?
Provide a succinct answer. 0.9. What is the ratio of the Expenditure(as % of GDP) in Small states in 2008 to that in 2011?
Give a very brief answer. 1.02. What is the ratio of the Expenditure(as % of GDP) in Lithuania in 2008 to that in 2011?
Provide a succinct answer. 0.73. What is the ratio of the Expenditure(as % of GDP) of Sao Tome and Principe in 2008 to that in 2011?
Offer a very short reply. 0.55. What is the ratio of the Expenditure(as % of GDP) of St. Vincent and the Grenadines in 2008 to that in 2011?
Ensure brevity in your answer.  0.89. What is the ratio of the Expenditure(as % of GDP) of Small states in 2009 to that in 2010?
Provide a succinct answer. 1.05. What is the ratio of the Expenditure(as % of GDP) in Lithuania in 2009 to that in 2010?
Your answer should be compact. 0.73. What is the ratio of the Expenditure(as % of GDP) of Sao Tome and Principe in 2009 to that in 2010?
Make the answer very short. 0.32. What is the ratio of the Expenditure(as % of GDP) of St. Vincent and the Grenadines in 2009 to that in 2010?
Give a very brief answer. 1.01. What is the ratio of the Expenditure(as % of GDP) in Small states in 2009 to that in 2011?
Provide a short and direct response. 1.1. What is the ratio of the Expenditure(as % of GDP) of Lithuania in 2009 to that in 2011?
Provide a succinct answer. 0.74. What is the ratio of the Expenditure(as % of GDP) of Sao Tome and Principe in 2009 to that in 2011?
Your response must be concise. 0.36. What is the ratio of the Expenditure(as % of GDP) in Small states in 2010 to that in 2011?
Keep it short and to the point. 1.05. What is the ratio of the Expenditure(as % of GDP) in Sao Tome and Principe in 2010 to that in 2011?
Provide a short and direct response. 1.14. What is the ratio of the Expenditure(as % of GDP) of St. Vincent and the Grenadines in 2010 to that in 2011?
Ensure brevity in your answer.  0.99. What is the difference between the highest and the second highest Expenditure(as % of GDP) of Small states?
Your answer should be very brief. 0.08. What is the difference between the highest and the second highest Expenditure(as % of GDP) in Lithuania?
Ensure brevity in your answer.  0.01. What is the difference between the highest and the second highest Expenditure(as % of GDP) in Sao Tome and Principe?
Ensure brevity in your answer.  0.39. What is the difference between the highest and the second highest Expenditure(as % of GDP) in St. Vincent and the Grenadines?
Provide a short and direct response. 0.11. What is the difference between the highest and the lowest Expenditure(as % of GDP) of Small states?
Ensure brevity in your answer.  0.68. What is the difference between the highest and the lowest Expenditure(as % of GDP) in Lithuania?
Keep it short and to the point. 1.65. What is the difference between the highest and the lowest Expenditure(as % of GDP) in Sao Tome and Principe?
Make the answer very short. 2.22. What is the difference between the highest and the lowest Expenditure(as % of GDP) of St. Vincent and the Grenadines?
Give a very brief answer. 0.58. 